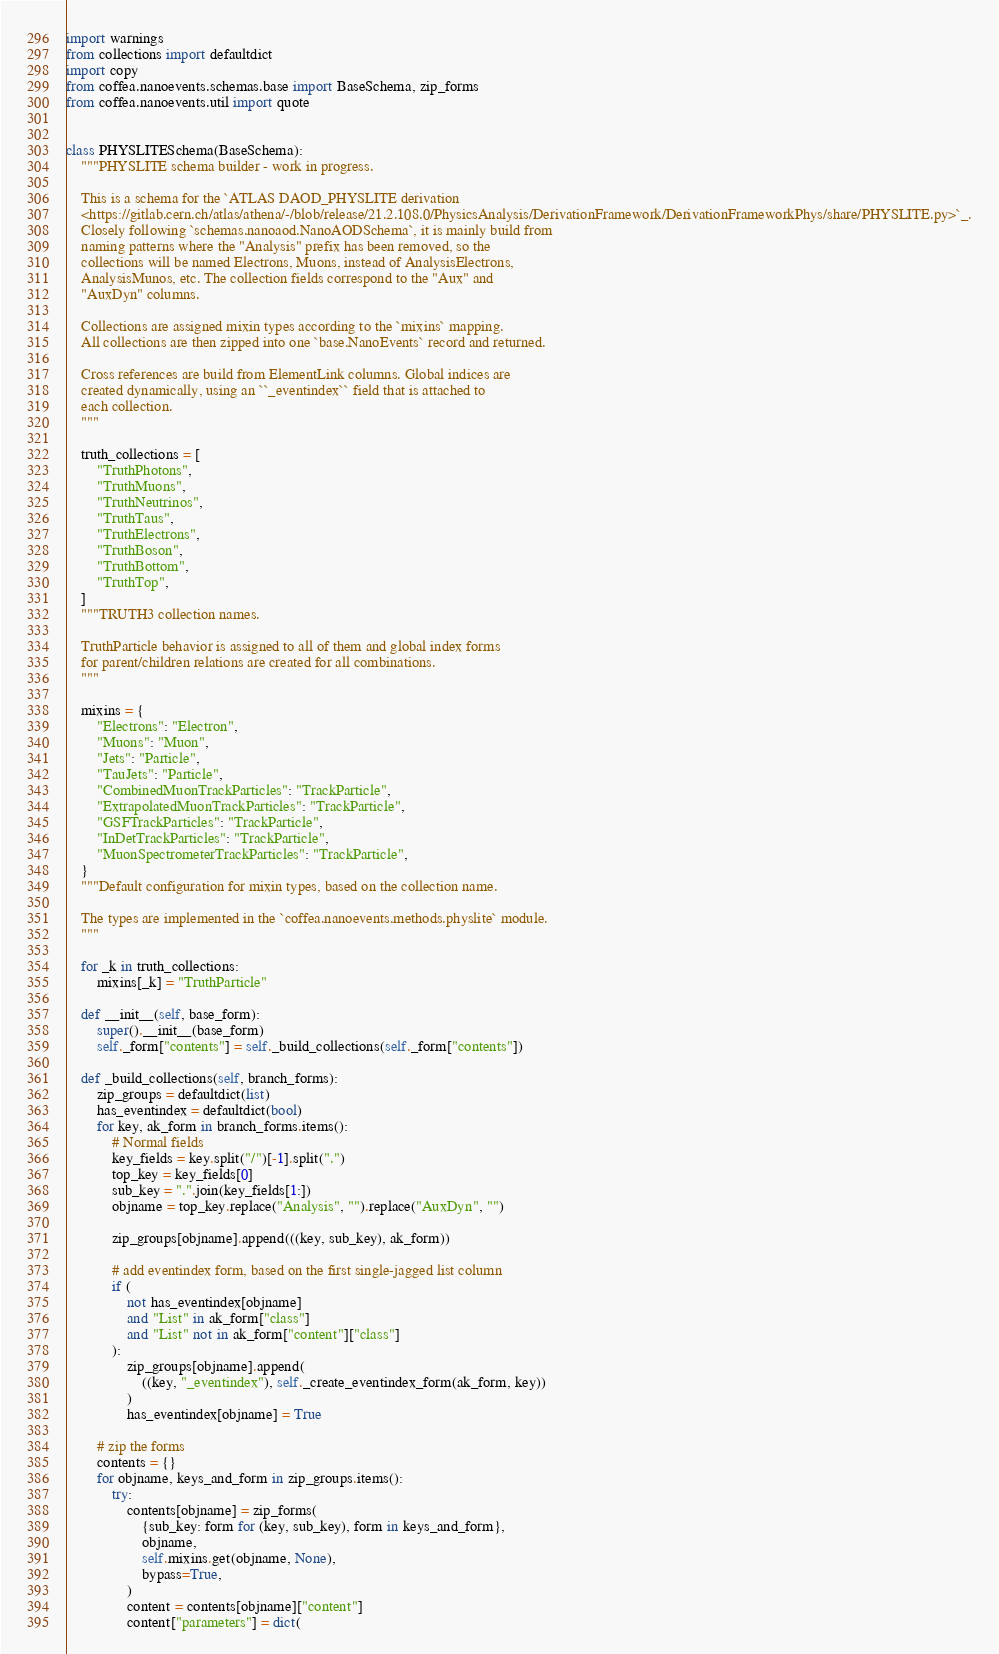Convert code to text. <code><loc_0><loc_0><loc_500><loc_500><_Python_>import warnings
from collections import defaultdict
import copy
from coffea.nanoevents.schemas.base import BaseSchema, zip_forms
from coffea.nanoevents.util import quote


class PHYSLITESchema(BaseSchema):
    """PHYSLITE schema builder - work in progress.

    This is a schema for the `ATLAS DAOD_PHYSLITE derivation
    <https://gitlab.cern.ch/atlas/athena/-/blob/release/21.2.108.0/PhysicsAnalysis/DerivationFramework/DerivationFrameworkPhys/share/PHYSLITE.py>`_.
    Closely following `schemas.nanoaod.NanoAODSchema`, it is mainly build from
    naming patterns where the "Analysis" prefix has been removed, so the
    collections will be named Electrons, Muons, instead of AnalysisElectrons,
    AnalysisMunos, etc. The collection fields correspond to the "Aux" and
    "AuxDyn" columns.

    Collections are assigned mixin types according to the `mixins` mapping.
    All collections are then zipped into one `base.NanoEvents` record and returned.

    Cross references are build from ElementLink columns. Global indices are
    created dynamically, using an ``_eventindex`` field that is attached to
    each collection.
    """

    truth_collections = [
        "TruthPhotons",
        "TruthMuons",
        "TruthNeutrinos",
        "TruthTaus",
        "TruthElectrons",
        "TruthBoson",
        "TruthBottom",
        "TruthTop",
    ]
    """TRUTH3 collection names.

    TruthParticle behavior is assigned to all of them and global index forms
    for parent/children relations are created for all combinations.
    """

    mixins = {
        "Electrons": "Electron",
        "Muons": "Muon",
        "Jets": "Particle",
        "TauJets": "Particle",
        "CombinedMuonTrackParticles": "TrackParticle",
        "ExtrapolatedMuonTrackParticles": "TrackParticle",
        "GSFTrackParticles": "TrackParticle",
        "InDetTrackParticles": "TrackParticle",
        "MuonSpectrometerTrackParticles": "TrackParticle",
    }
    """Default configuration for mixin types, based on the collection name.

    The types are implemented in the `coffea.nanoevents.methods.physlite` module.
    """

    for _k in truth_collections:
        mixins[_k] = "TruthParticle"

    def __init__(self, base_form):
        super().__init__(base_form)
        self._form["contents"] = self._build_collections(self._form["contents"])

    def _build_collections(self, branch_forms):
        zip_groups = defaultdict(list)
        has_eventindex = defaultdict(bool)
        for key, ak_form in branch_forms.items():
            # Normal fields
            key_fields = key.split("/")[-1].split(".")
            top_key = key_fields[0]
            sub_key = ".".join(key_fields[1:])
            objname = top_key.replace("Analysis", "").replace("AuxDyn", "")

            zip_groups[objname].append(((key, sub_key), ak_form))

            # add eventindex form, based on the first single-jagged list column
            if (
                not has_eventindex[objname]
                and "List" in ak_form["class"]
                and "List" not in ak_form["content"]["class"]
            ):
                zip_groups[objname].append(
                    ((key, "_eventindex"), self._create_eventindex_form(ak_form, key))
                )
                has_eventindex[objname] = True

        # zip the forms
        contents = {}
        for objname, keys_and_form in zip_groups.items():
            try:
                contents[objname] = zip_forms(
                    {sub_key: form for (key, sub_key), form in keys_and_form},
                    objname,
                    self.mixins.get(objname, None),
                    bypass=True,
                )
                content = contents[objname]["content"]
                content["parameters"] = dict(</code> 